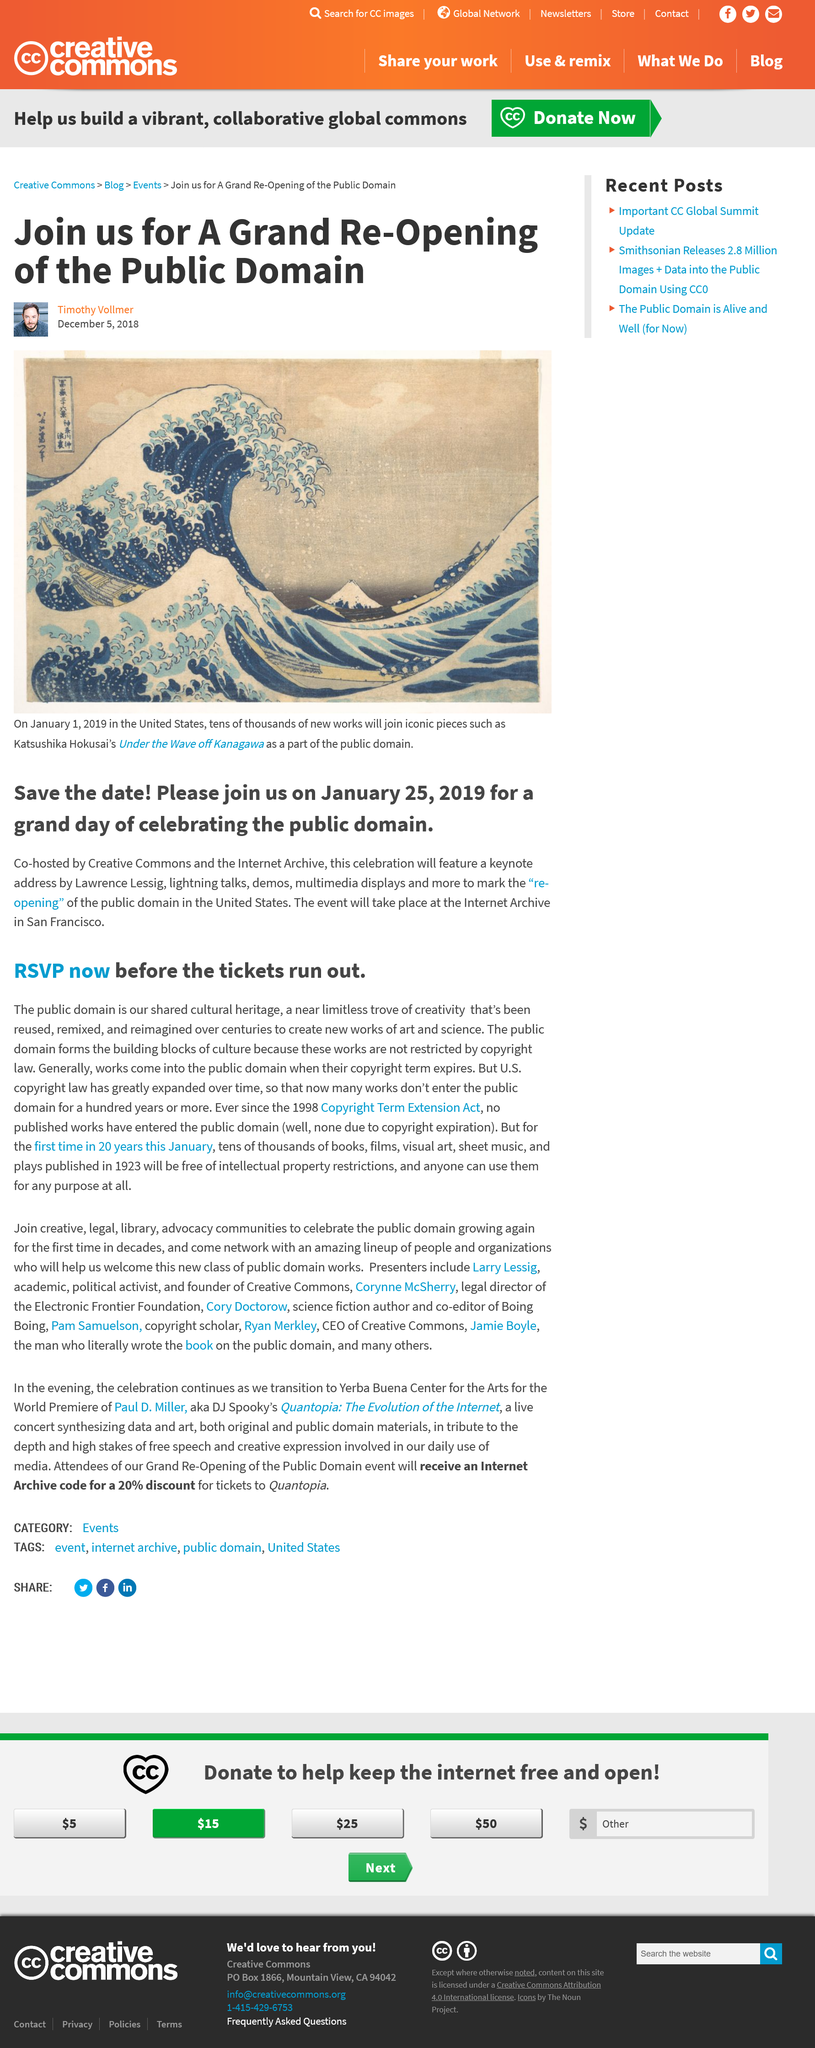Mention a couple of crucial points in this snapshot. Before 1998, most works entered the public domain once their copyright expired. In the United States, many new works will soon join the public domain. On January 25th, 2019, Creative Commons and the Internet Archive will be co-hosting a public domain celebration. It is permissible for individuals to utilize documents and materials in the public domain for any purpose without restriction or permission. The public domain is the building blocks of culture, as described by the author. 